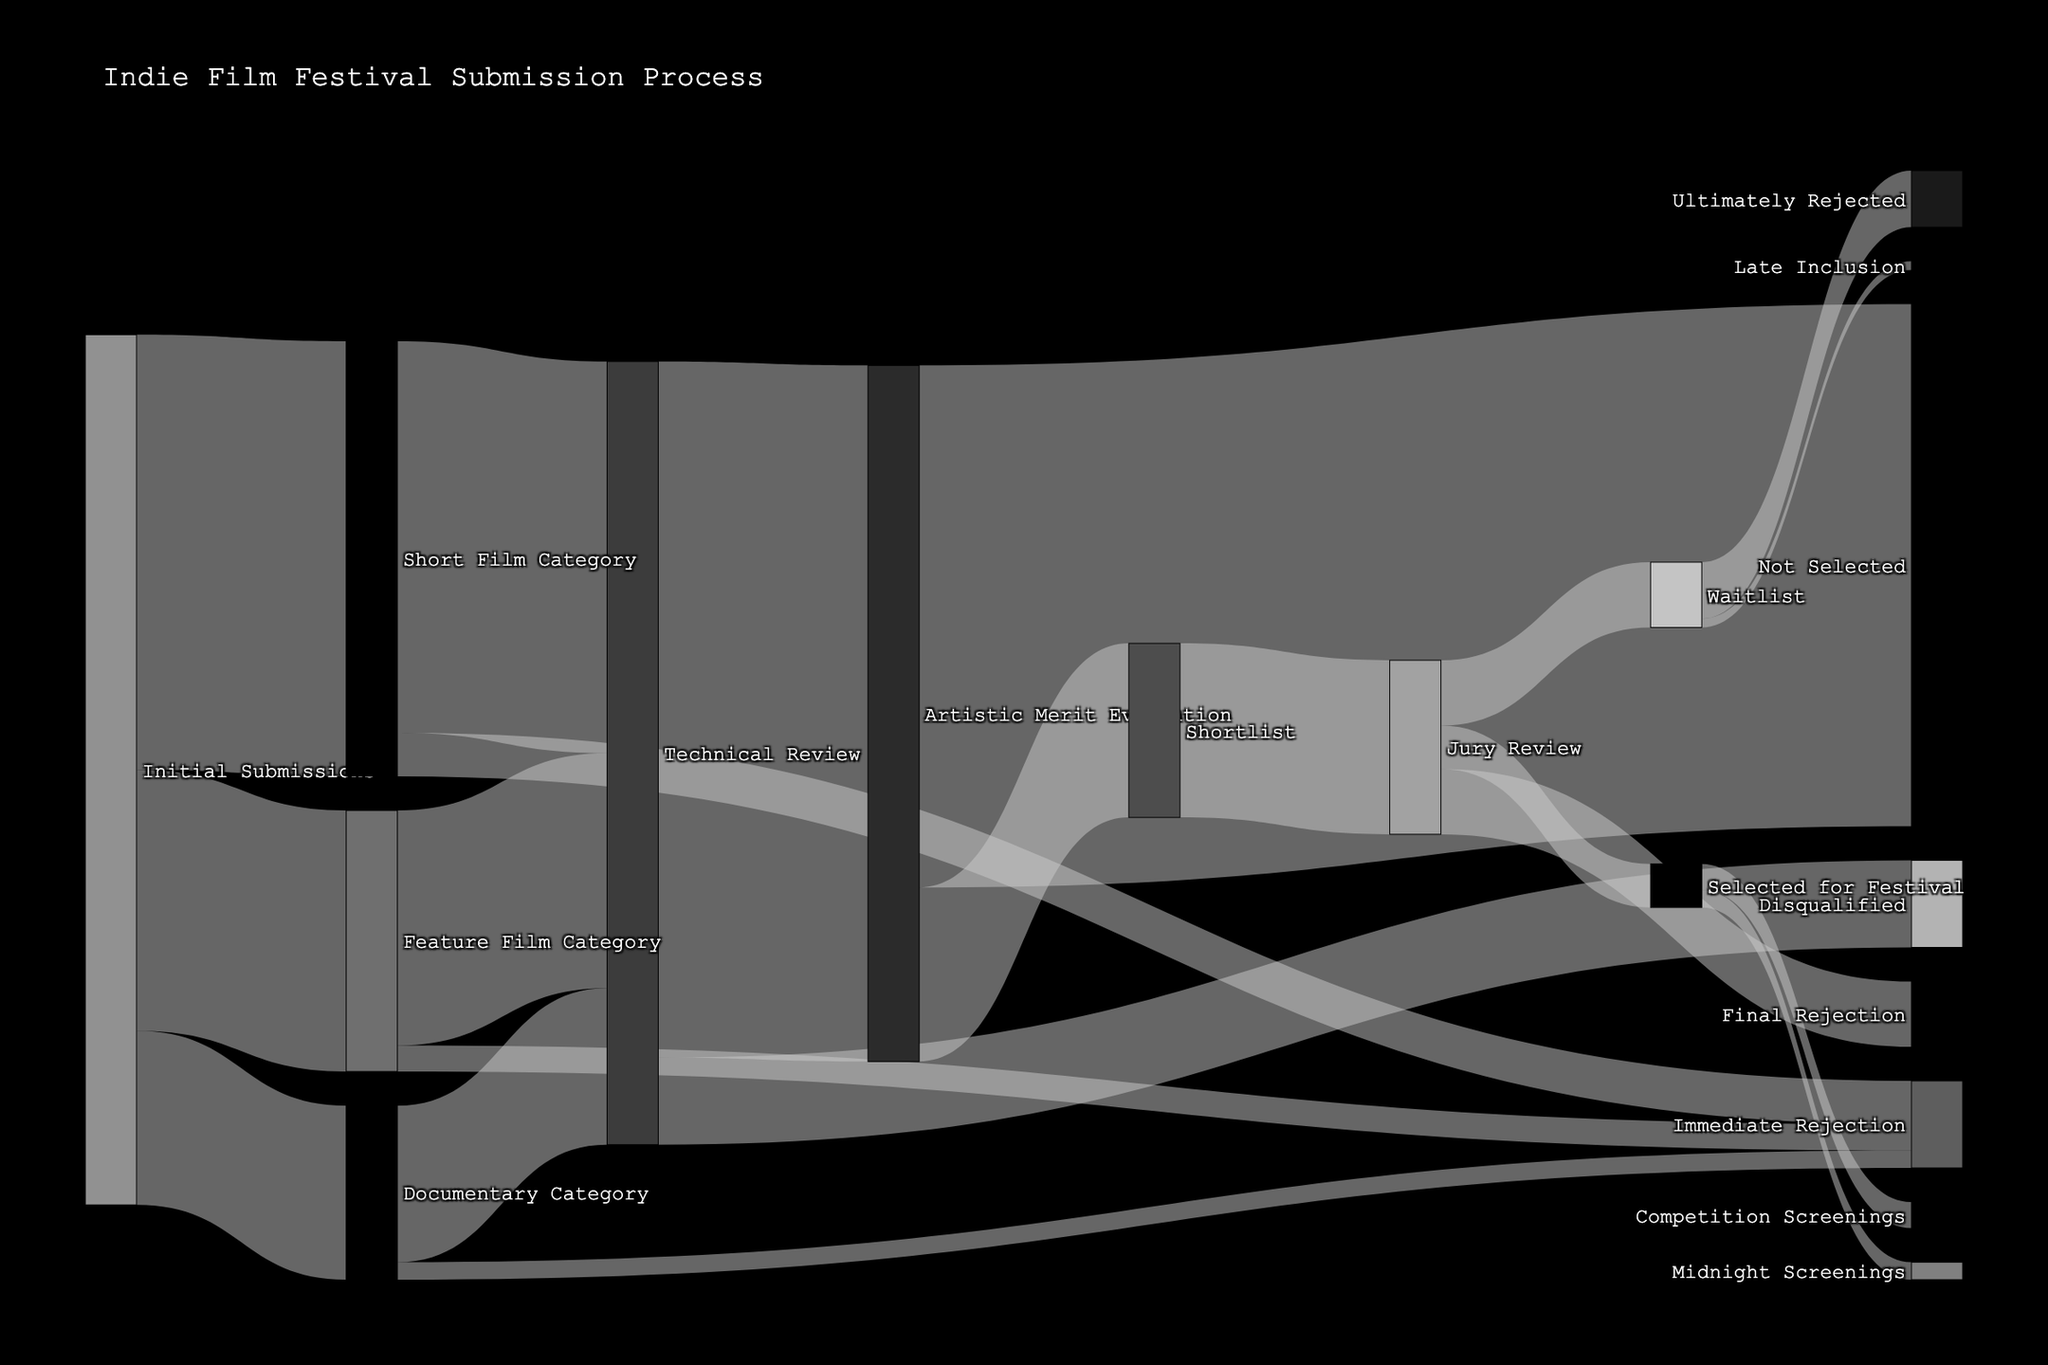How many films were initially submitted to the festival? By directly looking at the first step of the sankey diagram, summing up the values for each film category: 500 (Short Film) + 300 (Feature Film) + 200 (Documentary) = 1000.
Answer: 1000 What happens to the films after the technical review stage? Observing the diagram, the technical review stage branches into two paths: 800 films go to Artistic Merit Evaluation, and 100 films are Disqualified.
Answer: Artistic Merit Evaluation or Disqualification Which category had the most immediate rejections? Comparing the immediate rejection values across the categories: Short Film (50), Feature Film (30), Documentary (20). The Short Film category has the highest immediate rejection count of 50.
Answer: Short Film How many films make it to the Jury Review stage? Looking at the path leading to the Jury Review, all entries come from the Shortlist, which shows a value of 200.
Answer: 200 Of all films that reached Jury Review, how many were finally selected for the festival? By following the distribution within Jury Review, we see 50 films are Selected for Festival.
Answer: 50 How many films were disqualified during the Technical Review? Directly checking the Technical Review's outgoing paths, we see that 100 films were disqualified.
Answer: 100 What is the total number of films evaluated for Artistic Merit? The other path from Technical Review is Artistic Merit Evaluation which has a single value of 800.
Answer: 800 What is the difference between the number of films not selected based on Artistic Merit Evaluation and those shortlisted? From Artistic Merit Evaluation: Not Selected (600) and Shortlist (200). The difference is 600 - 200 = 400.
Answer: 400 What percentage of initially submitted films reached the Artistic Merit Evaluation stage? We need to calculate the percentage based on initial submissions (1000) and those that reached Artistic Merit Evaluation (800). The percentage is (800 / 1000) * 100% = 80%.
Answer: 80% Which screening type has fewer selected films, Midnight Screenings or Competition Screenings, and by how many? Comparing values in the selected category: Midnight Screenings (20) and Competition Screenings (30). Midnight Screenings have fewer by 10 (30 - 20).
Answer: Midnight Screenings by 10 